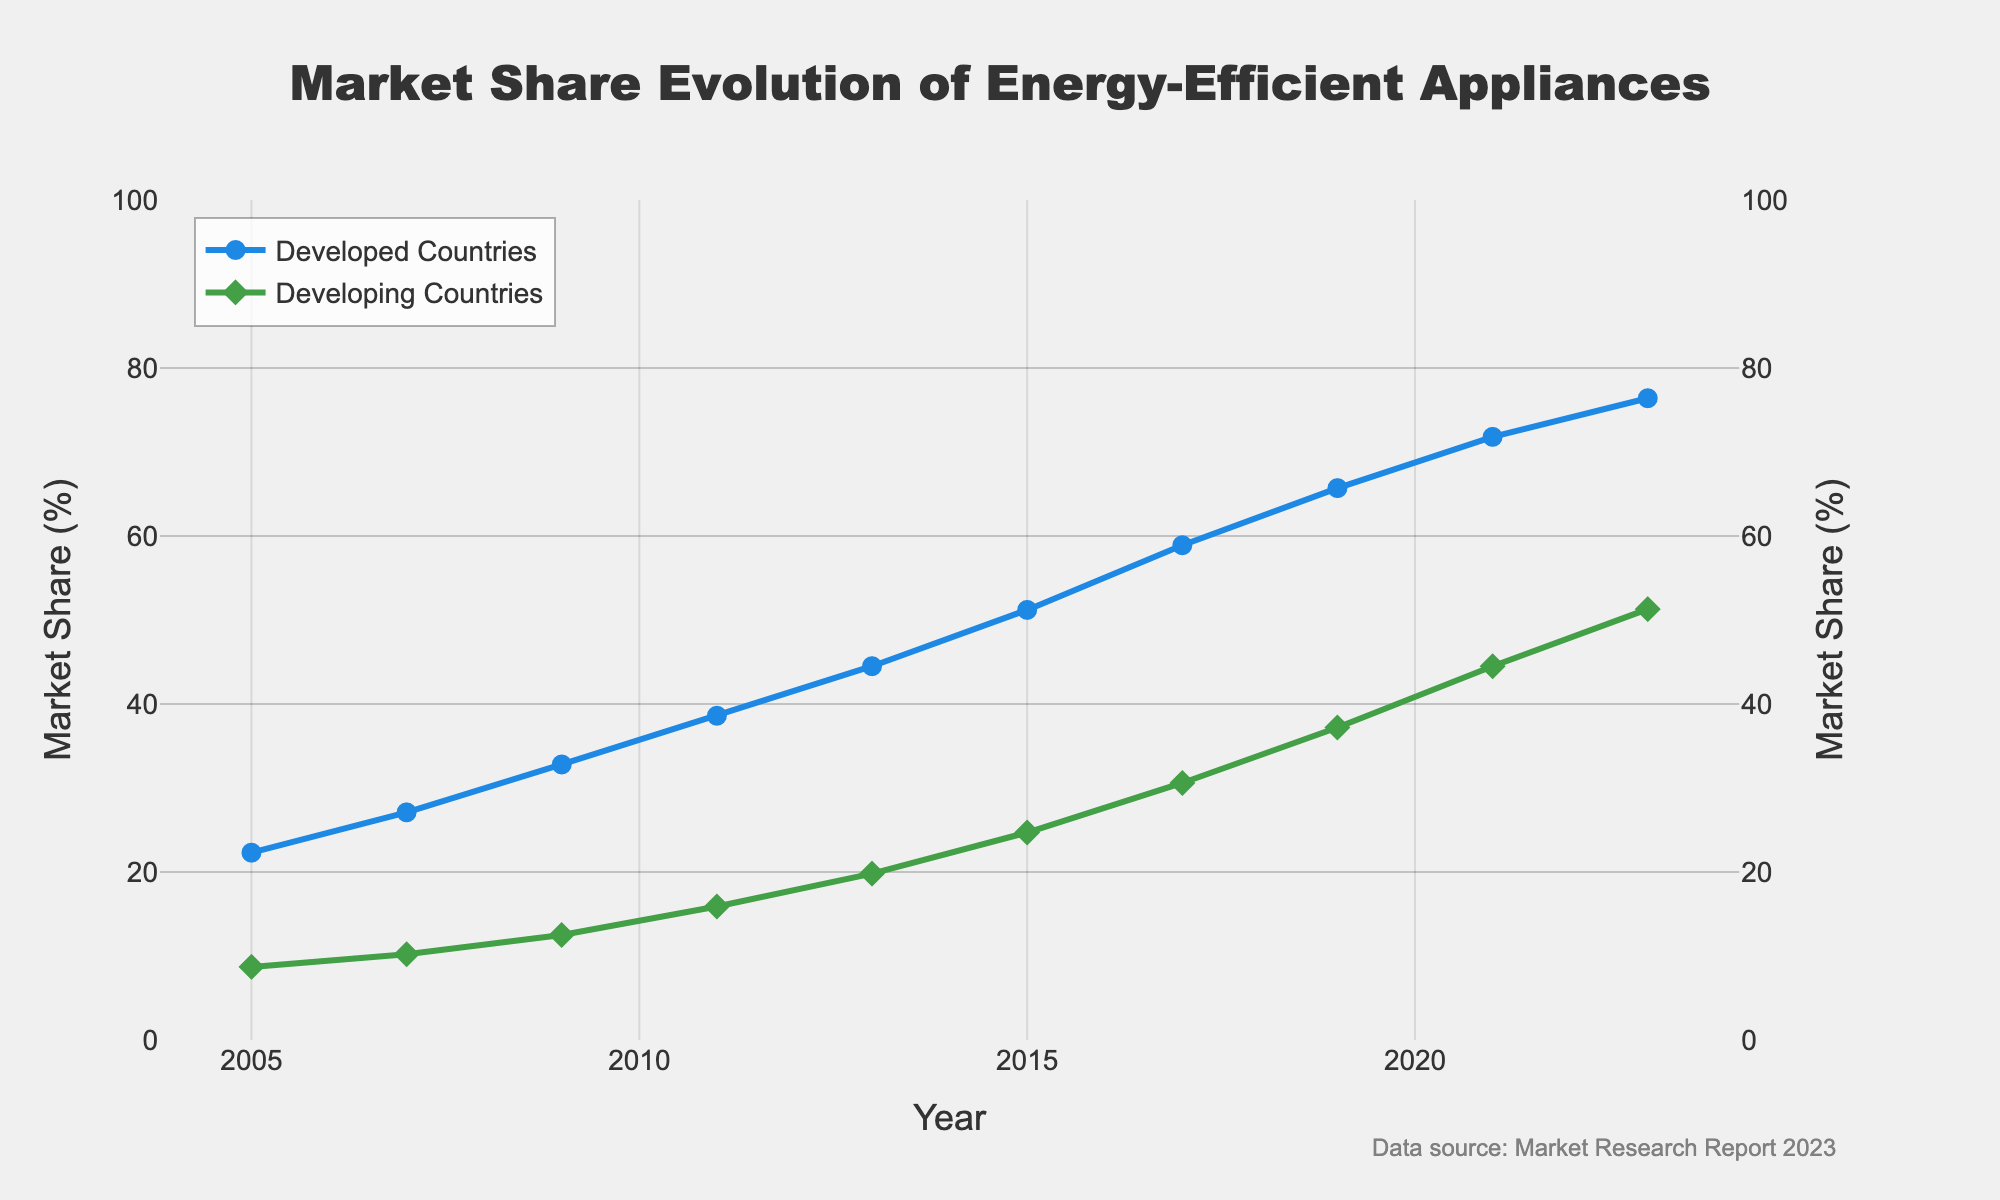What is the overall trend in the market share of energy-efficient appliances in developed countries from 2005 to 2023? The line representing developed countries consistently increases from 22.3% in 2005 to 76.4% in 2023, indicating a steady upward trend.
Answer: Upward Which country group had a higher market share in 2009, developed countries or developing countries? In 2009, the market share in developed countries was 32.8%, while in developing countries it was 12.5%. Thus, developed countries had a higher market share.
Answer: Developed countries By how much did the market share of energy-efficient appliances in developing countries increase between 2017 and 2019? The market share in developing countries increased from 30.6% in 2017 to 37.2% in 2019. The increase is 37.2% - 30.6% = 6.6%.
Answer: 6.6% During which two-year period did the market share of energy-efficient appliances in developed countries grow the most? From 2019 to 2021, the market share in developed countries grew from 65.7% to 71.8%. The increase is 71.8% - 65.7% = 6.1%, which is the largest growth compared to other two-year periods.
Answer: 2019-2021 On which axis (left or right) is the market share of developing countries plotted? The market share of developing countries is plotted on the right axis, indicated by the placement of green markers aligned with the green line.
Answer: Right What is the difference in market share of energy-efficient appliances between developed and developing countries in 2023? In 2023, the market share for developed countries is 76.4% and for developing countries is 51.3%. The difference is 76.4% - 51.3% = 25.1%.
Answer: 25.1% By how much did the market share of energy-efficient appliances in developed countries increase between 2005 and 2015? The market share in developed countries increased from 22.3% in 2005 to 51.2% in 2015. The increase is 51.2% - 22.3% = 28.9%.
Answer: 28.9% Which year shows the closest market share between developed and developing countries? The market shares in developed and developing countries are closest in 2023, with shares being 76.4% and 51.3%, respectively, giving a difference of 25.1%, which is the smallest difference over the years.
Answer: 2023 Between 2005 and 2023, which group of countries showed a higher average annual increase in market share of energy-efficient appliances? The average annual increase can be calculated by taking the difference of the market shares in 2023 and 2005, then dividing by the number of years. Developed countries: (76.4 - 22.3)/18 = 3.0% per year. Developing countries: (51.3 - 8.7)/18 = 2.37% per year. Developed countries showed a higher average annual increase.
Answer: Developed countries 